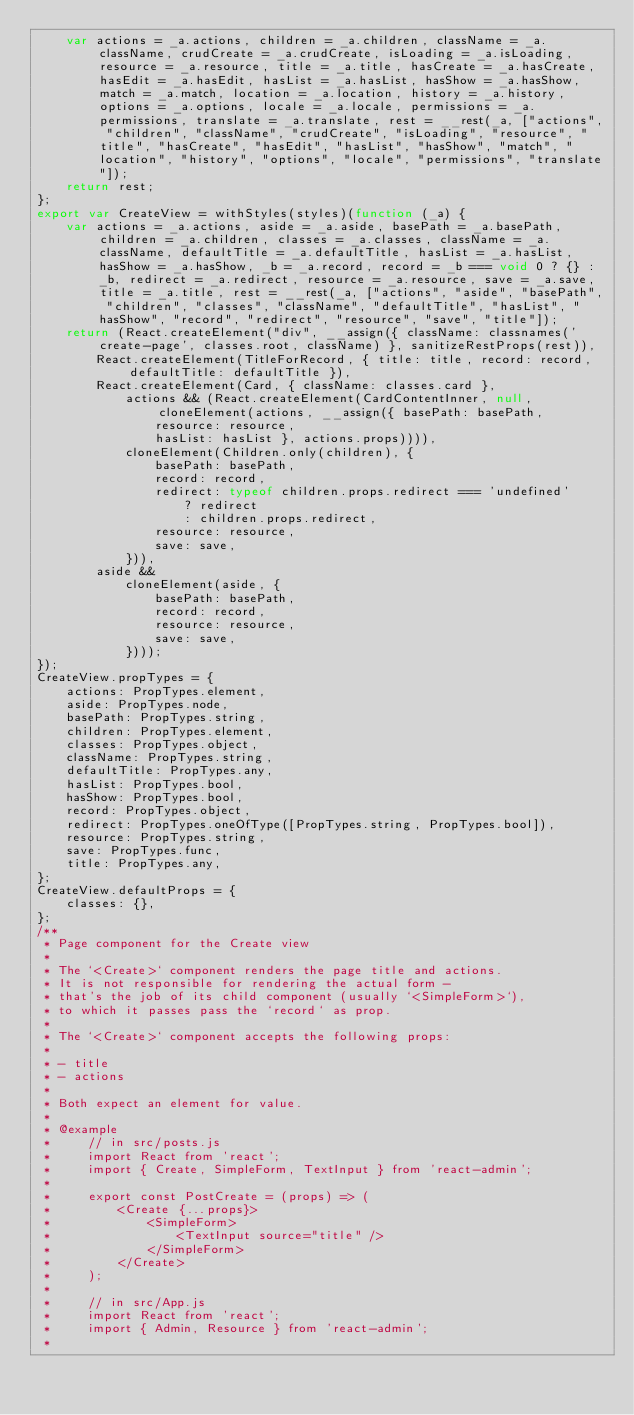Convert code to text. <code><loc_0><loc_0><loc_500><loc_500><_JavaScript_>    var actions = _a.actions, children = _a.children, className = _a.className, crudCreate = _a.crudCreate, isLoading = _a.isLoading, resource = _a.resource, title = _a.title, hasCreate = _a.hasCreate, hasEdit = _a.hasEdit, hasList = _a.hasList, hasShow = _a.hasShow, match = _a.match, location = _a.location, history = _a.history, options = _a.options, locale = _a.locale, permissions = _a.permissions, translate = _a.translate, rest = __rest(_a, ["actions", "children", "className", "crudCreate", "isLoading", "resource", "title", "hasCreate", "hasEdit", "hasList", "hasShow", "match", "location", "history", "options", "locale", "permissions", "translate"]);
    return rest;
};
export var CreateView = withStyles(styles)(function (_a) {
    var actions = _a.actions, aside = _a.aside, basePath = _a.basePath, children = _a.children, classes = _a.classes, className = _a.className, defaultTitle = _a.defaultTitle, hasList = _a.hasList, hasShow = _a.hasShow, _b = _a.record, record = _b === void 0 ? {} : _b, redirect = _a.redirect, resource = _a.resource, save = _a.save, title = _a.title, rest = __rest(_a, ["actions", "aside", "basePath", "children", "classes", "className", "defaultTitle", "hasList", "hasShow", "record", "redirect", "resource", "save", "title"]);
    return (React.createElement("div", __assign({ className: classnames('create-page', classes.root, className) }, sanitizeRestProps(rest)),
        React.createElement(TitleForRecord, { title: title, record: record, defaultTitle: defaultTitle }),
        React.createElement(Card, { className: classes.card },
            actions && (React.createElement(CardContentInner, null, cloneElement(actions, __assign({ basePath: basePath,
                resource: resource,
                hasList: hasList }, actions.props)))),
            cloneElement(Children.only(children), {
                basePath: basePath,
                record: record,
                redirect: typeof children.props.redirect === 'undefined'
                    ? redirect
                    : children.props.redirect,
                resource: resource,
                save: save,
            })),
        aside &&
            cloneElement(aside, {
                basePath: basePath,
                record: record,
                resource: resource,
                save: save,
            })));
});
CreateView.propTypes = {
    actions: PropTypes.element,
    aside: PropTypes.node,
    basePath: PropTypes.string,
    children: PropTypes.element,
    classes: PropTypes.object,
    className: PropTypes.string,
    defaultTitle: PropTypes.any,
    hasList: PropTypes.bool,
    hasShow: PropTypes.bool,
    record: PropTypes.object,
    redirect: PropTypes.oneOfType([PropTypes.string, PropTypes.bool]),
    resource: PropTypes.string,
    save: PropTypes.func,
    title: PropTypes.any,
};
CreateView.defaultProps = {
    classes: {},
};
/**
 * Page component for the Create view
 *
 * The `<Create>` component renders the page title and actions.
 * It is not responsible for rendering the actual form -
 * that's the job of its child component (usually `<SimpleForm>`),
 * to which it passes pass the `record` as prop.
 *
 * The `<Create>` component accepts the following props:
 *
 * - title
 * - actions
 *
 * Both expect an element for value.
 *
 * @example
 *     // in src/posts.js
 *     import React from 'react';
 *     import { Create, SimpleForm, TextInput } from 'react-admin';
 *
 *     export const PostCreate = (props) => (
 *         <Create {...props}>
 *             <SimpleForm>
 *                 <TextInput source="title" />
 *             </SimpleForm>
 *         </Create>
 *     );
 *
 *     // in src/App.js
 *     import React from 'react';
 *     import { Admin, Resource } from 'react-admin';
 *</code> 